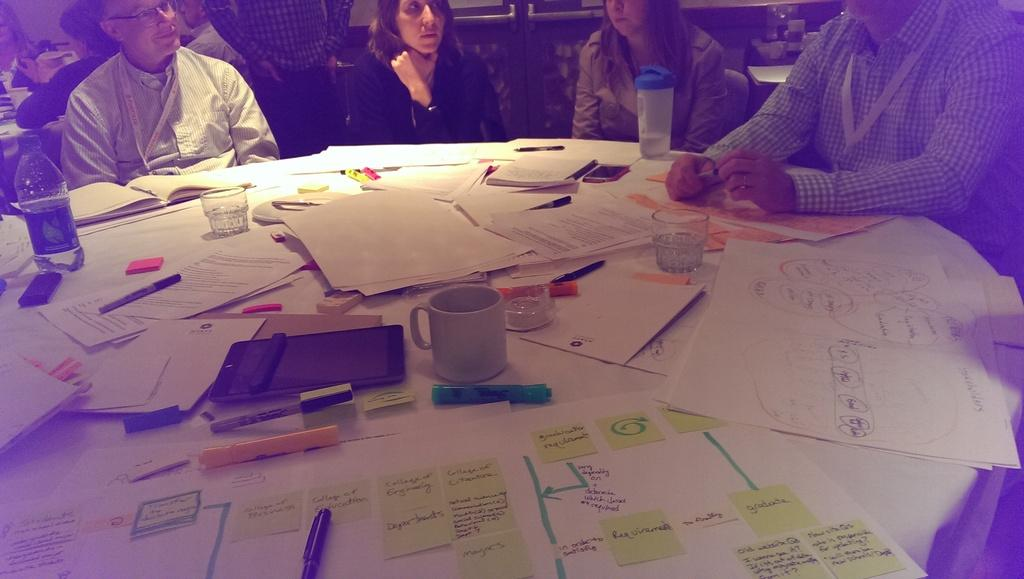What are the people in the image doing? The people in the image are sitting around the table. What objects can be seen on the table? There are papers, glasses, lens, mobile phones, and bottles on the table. What might the people be using the glasses for? The glasses might be used for drinking or holding items. What could the lens be used for? The lens could be used for photography or other optical purposes. How does the cream control the heat in the image? There is no cream present in the image, so it cannot control any heat. 